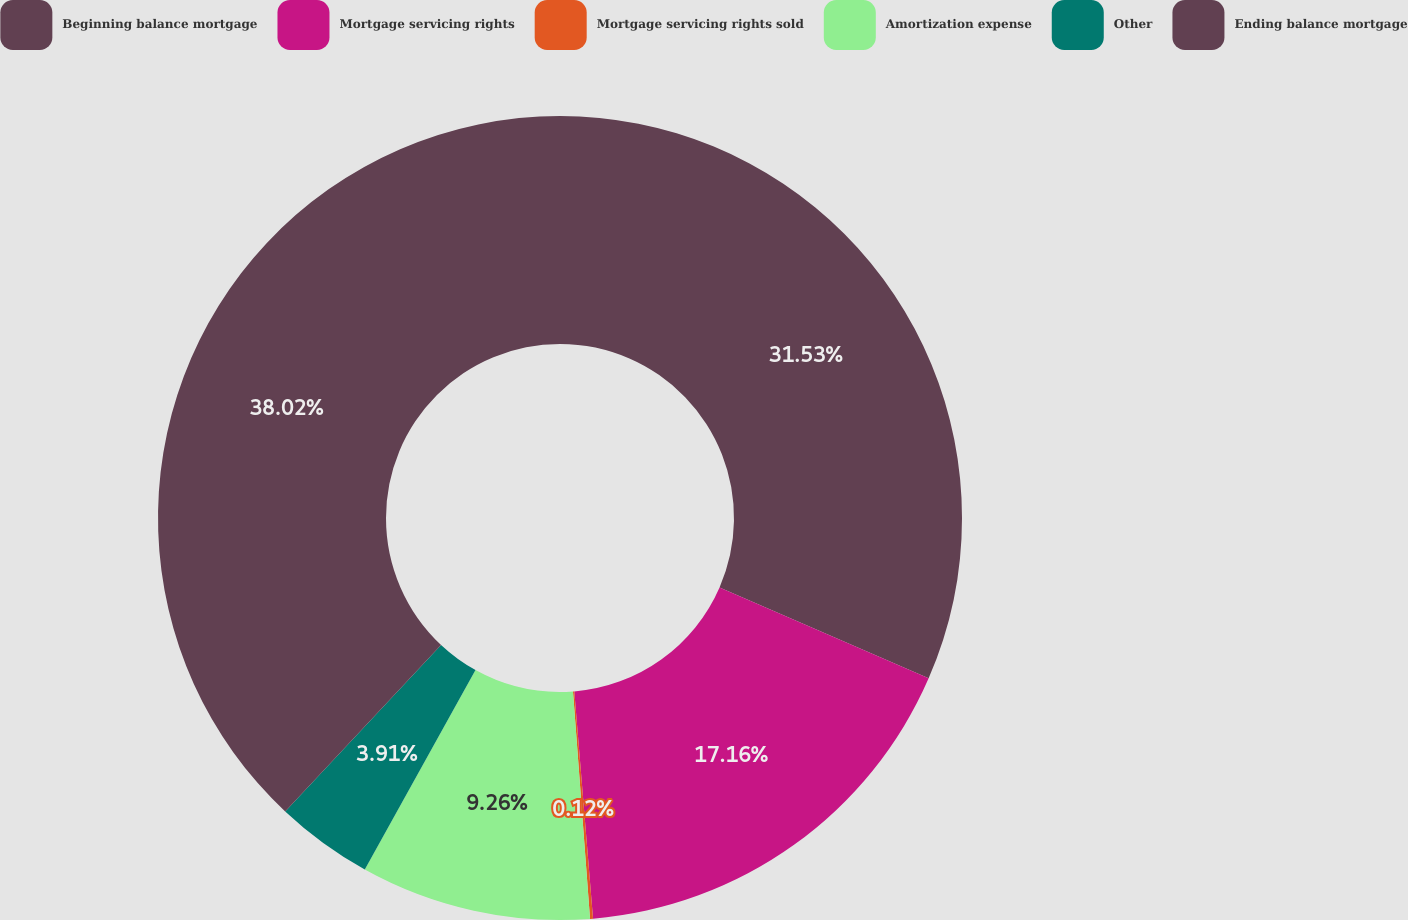<chart> <loc_0><loc_0><loc_500><loc_500><pie_chart><fcel>Beginning balance mortgage<fcel>Mortgage servicing rights<fcel>Mortgage servicing rights sold<fcel>Amortization expense<fcel>Other<fcel>Ending balance mortgage<nl><fcel>31.53%<fcel>17.16%<fcel>0.12%<fcel>9.26%<fcel>3.91%<fcel>38.02%<nl></chart> 